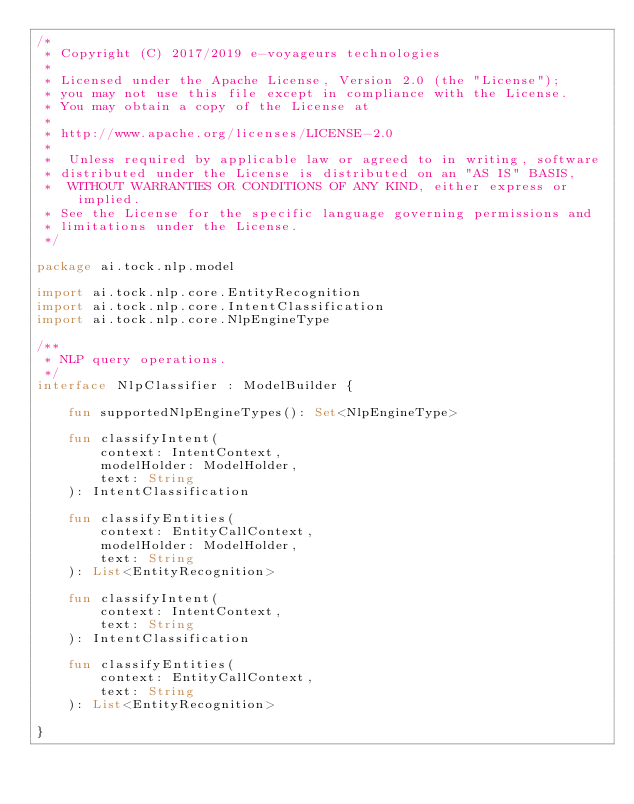Convert code to text. <code><loc_0><loc_0><loc_500><loc_500><_Kotlin_>/*
 * Copyright (C) 2017/2019 e-voyageurs technologies
 *
 * Licensed under the Apache License, Version 2.0 (the "License");
 * you may not use this file except in compliance with the License.
 * You may obtain a copy of the License at
 *
 * http://www.apache.org/licenses/LICENSE-2.0
 *
 *  Unless required by applicable law or agreed to in writing, software
 * distributed under the License is distributed on an "AS IS" BASIS,
 *  WITHOUT WARRANTIES OR CONDITIONS OF ANY KIND, either express or implied.
 * See the License for the specific language governing permissions and
 * limitations under the License.
 */

package ai.tock.nlp.model

import ai.tock.nlp.core.EntityRecognition
import ai.tock.nlp.core.IntentClassification
import ai.tock.nlp.core.NlpEngineType

/**
 * NLP query operations.
 */
interface NlpClassifier : ModelBuilder {

    fun supportedNlpEngineTypes(): Set<NlpEngineType>

    fun classifyIntent(
        context: IntentContext,
        modelHolder: ModelHolder,
        text: String
    ): IntentClassification

    fun classifyEntities(
        context: EntityCallContext,
        modelHolder: ModelHolder,
        text: String
    ): List<EntityRecognition>

    fun classifyIntent(
        context: IntentContext,
        text: String
    ): IntentClassification

    fun classifyEntities(
        context: EntityCallContext,
        text: String
    ): List<EntityRecognition>

}</code> 